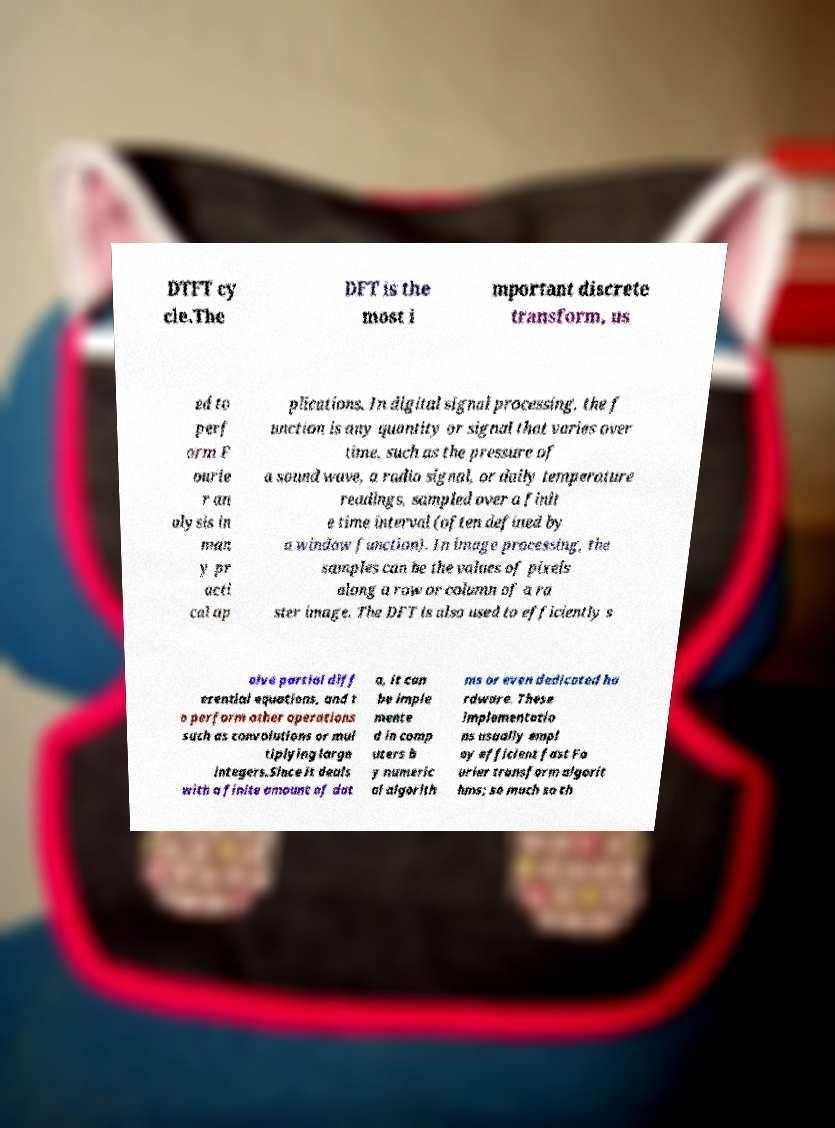Please read and relay the text visible in this image. What does it say? DTFT cy cle.The DFT is the most i mportant discrete transform, us ed to perf orm F ourie r an alysis in man y pr acti cal ap plications. In digital signal processing, the f unction is any quantity or signal that varies over time, such as the pressure of a sound wave, a radio signal, or daily temperature readings, sampled over a finit e time interval (often defined by a window function). In image processing, the samples can be the values of pixels along a row or column of a ra ster image. The DFT is also used to efficiently s olve partial diff erential equations, and t o perform other operations such as convolutions or mul tiplying large integers.Since it deals with a finite amount of dat a, it can be imple mente d in comp uters b y numeric al algorith ms or even dedicated ha rdware. These implementatio ns usually empl oy efficient fast Fo urier transform algorit hms; so much so th 